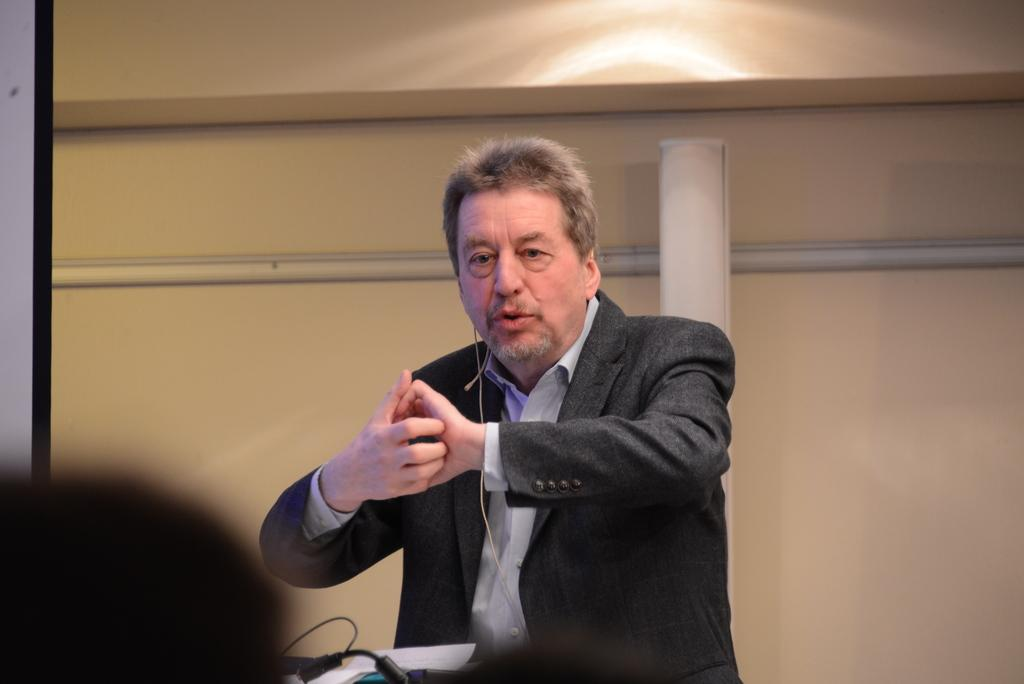Who is present in the image? There is a person in the image. What is the person wearing? The person is wearing a suit. Where is the person standing in the image? The person is standing in front of a desk. What can be seen on the desk? There are things placed on the desk. What type of thread is the person using to pull the pets in the image? There are no pets or thread present in the image. 